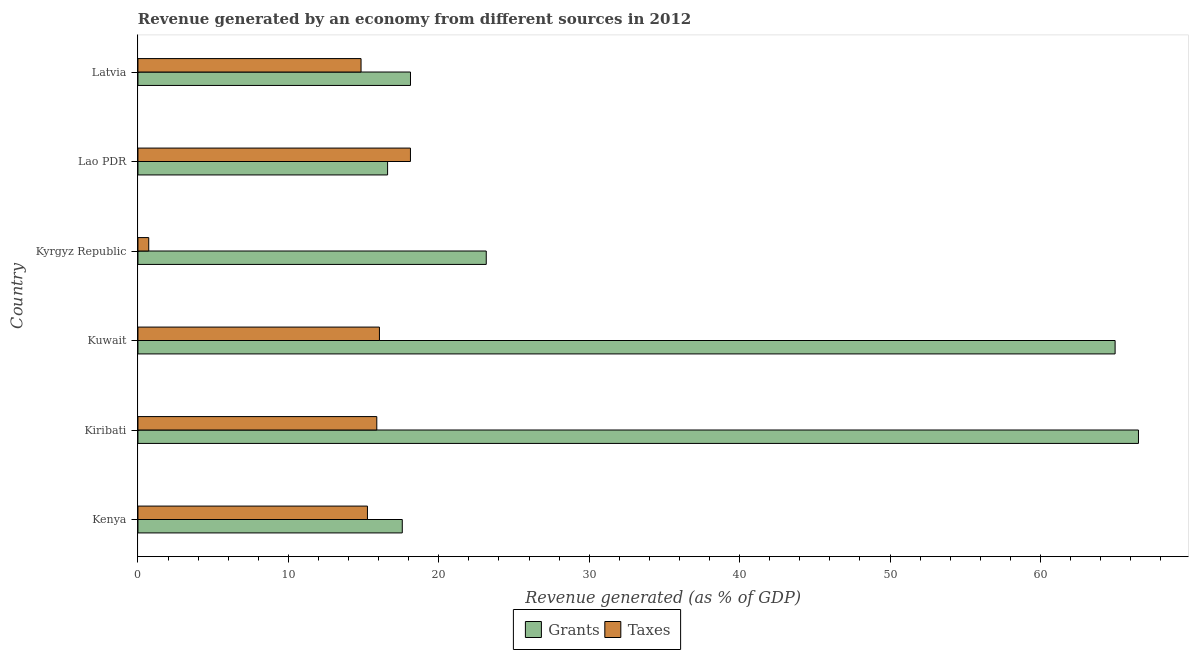How many different coloured bars are there?
Provide a succinct answer. 2. Are the number of bars per tick equal to the number of legend labels?
Provide a succinct answer. Yes. Are the number of bars on each tick of the Y-axis equal?
Your answer should be very brief. Yes. How many bars are there on the 6th tick from the top?
Your answer should be very brief. 2. What is the label of the 6th group of bars from the top?
Ensure brevity in your answer.  Kenya. What is the revenue generated by taxes in Kyrgyz Republic?
Make the answer very short. 0.72. Across all countries, what is the maximum revenue generated by taxes?
Your answer should be very brief. 18.12. Across all countries, what is the minimum revenue generated by taxes?
Provide a short and direct response. 0.72. In which country was the revenue generated by taxes maximum?
Keep it short and to the point. Lao PDR. In which country was the revenue generated by grants minimum?
Your answer should be compact. Lao PDR. What is the total revenue generated by grants in the graph?
Keep it short and to the point. 206.93. What is the difference between the revenue generated by taxes in Kyrgyz Republic and that in Lao PDR?
Give a very brief answer. -17.4. What is the difference between the revenue generated by grants in Kuwait and the revenue generated by taxes in Kiribati?
Your answer should be very brief. 49.09. What is the average revenue generated by taxes per country?
Keep it short and to the point. 13.48. What is the difference between the revenue generated by taxes and revenue generated by grants in Kyrgyz Republic?
Provide a short and direct response. -22.44. Is the revenue generated by taxes in Kyrgyz Republic less than that in Lao PDR?
Offer a terse response. Yes. What is the difference between the highest and the second highest revenue generated by grants?
Provide a succinct answer. 1.55. In how many countries, is the revenue generated by grants greater than the average revenue generated by grants taken over all countries?
Keep it short and to the point. 2. What does the 2nd bar from the top in Latvia represents?
Give a very brief answer. Grants. What does the 1st bar from the bottom in Kiribati represents?
Keep it short and to the point. Grants. Are all the bars in the graph horizontal?
Keep it short and to the point. Yes. Does the graph contain any zero values?
Give a very brief answer. No. Does the graph contain grids?
Offer a terse response. No. Where does the legend appear in the graph?
Provide a succinct answer. Bottom center. How many legend labels are there?
Make the answer very short. 2. How are the legend labels stacked?
Offer a very short reply. Horizontal. What is the title of the graph?
Offer a terse response. Revenue generated by an economy from different sources in 2012. Does "Mobile cellular" appear as one of the legend labels in the graph?
Your answer should be very brief. No. What is the label or title of the X-axis?
Give a very brief answer. Revenue generated (as % of GDP). What is the label or title of the Y-axis?
Keep it short and to the point. Country. What is the Revenue generated (as % of GDP) of Grants in Kenya?
Provide a succinct answer. 17.57. What is the Revenue generated (as % of GDP) of Taxes in Kenya?
Your answer should be very brief. 15.26. What is the Revenue generated (as % of GDP) of Grants in Kiribati?
Give a very brief answer. 66.52. What is the Revenue generated (as % of GDP) of Taxes in Kiribati?
Your answer should be very brief. 15.88. What is the Revenue generated (as % of GDP) of Grants in Kuwait?
Make the answer very short. 64.96. What is the Revenue generated (as % of GDP) in Taxes in Kuwait?
Keep it short and to the point. 16.05. What is the Revenue generated (as % of GDP) of Grants in Kyrgyz Republic?
Offer a very short reply. 23.16. What is the Revenue generated (as % of GDP) of Taxes in Kyrgyz Republic?
Make the answer very short. 0.72. What is the Revenue generated (as % of GDP) in Grants in Lao PDR?
Make the answer very short. 16.6. What is the Revenue generated (as % of GDP) of Taxes in Lao PDR?
Give a very brief answer. 18.12. What is the Revenue generated (as % of GDP) of Grants in Latvia?
Ensure brevity in your answer.  18.12. What is the Revenue generated (as % of GDP) in Taxes in Latvia?
Your answer should be very brief. 14.83. Across all countries, what is the maximum Revenue generated (as % of GDP) in Grants?
Provide a succinct answer. 66.52. Across all countries, what is the maximum Revenue generated (as % of GDP) of Taxes?
Make the answer very short. 18.12. Across all countries, what is the minimum Revenue generated (as % of GDP) in Grants?
Keep it short and to the point. 16.6. Across all countries, what is the minimum Revenue generated (as % of GDP) in Taxes?
Your answer should be very brief. 0.72. What is the total Revenue generated (as % of GDP) in Grants in the graph?
Your answer should be compact. 206.93. What is the total Revenue generated (as % of GDP) in Taxes in the graph?
Your answer should be very brief. 80.86. What is the difference between the Revenue generated (as % of GDP) of Grants in Kenya and that in Kiribati?
Ensure brevity in your answer.  -48.94. What is the difference between the Revenue generated (as % of GDP) of Taxes in Kenya and that in Kiribati?
Make the answer very short. -0.62. What is the difference between the Revenue generated (as % of GDP) in Grants in Kenya and that in Kuwait?
Your answer should be very brief. -47.39. What is the difference between the Revenue generated (as % of GDP) of Taxes in Kenya and that in Kuwait?
Ensure brevity in your answer.  -0.8. What is the difference between the Revenue generated (as % of GDP) in Grants in Kenya and that in Kyrgyz Republic?
Your response must be concise. -5.58. What is the difference between the Revenue generated (as % of GDP) of Taxes in Kenya and that in Kyrgyz Republic?
Provide a short and direct response. 14.54. What is the difference between the Revenue generated (as % of GDP) in Grants in Kenya and that in Lao PDR?
Your answer should be compact. 0.98. What is the difference between the Revenue generated (as % of GDP) of Taxes in Kenya and that in Lao PDR?
Your answer should be compact. -2.86. What is the difference between the Revenue generated (as % of GDP) in Grants in Kenya and that in Latvia?
Your response must be concise. -0.55. What is the difference between the Revenue generated (as % of GDP) in Taxes in Kenya and that in Latvia?
Provide a succinct answer. 0.43. What is the difference between the Revenue generated (as % of GDP) in Grants in Kiribati and that in Kuwait?
Provide a short and direct response. 1.55. What is the difference between the Revenue generated (as % of GDP) in Taxes in Kiribati and that in Kuwait?
Give a very brief answer. -0.18. What is the difference between the Revenue generated (as % of GDP) of Grants in Kiribati and that in Kyrgyz Republic?
Offer a terse response. 43.36. What is the difference between the Revenue generated (as % of GDP) of Taxes in Kiribati and that in Kyrgyz Republic?
Ensure brevity in your answer.  15.16. What is the difference between the Revenue generated (as % of GDP) in Grants in Kiribati and that in Lao PDR?
Your response must be concise. 49.92. What is the difference between the Revenue generated (as % of GDP) of Taxes in Kiribati and that in Lao PDR?
Provide a succinct answer. -2.24. What is the difference between the Revenue generated (as % of GDP) of Grants in Kiribati and that in Latvia?
Your answer should be compact. 48.4. What is the difference between the Revenue generated (as % of GDP) in Taxes in Kiribati and that in Latvia?
Keep it short and to the point. 1.05. What is the difference between the Revenue generated (as % of GDP) of Grants in Kuwait and that in Kyrgyz Republic?
Your response must be concise. 41.81. What is the difference between the Revenue generated (as % of GDP) in Taxes in Kuwait and that in Kyrgyz Republic?
Provide a succinct answer. 15.34. What is the difference between the Revenue generated (as % of GDP) of Grants in Kuwait and that in Lao PDR?
Your response must be concise. 48.37. What is the difference between the Revenue generated (as % of GDP) of Taxes in Kuwait and that in Lao PDR?
Offer a terse response. -2.06. What is the difference between the Revenue generated (as % of GDP) of Grants in Kuwait and that in Latvia?
Your answer should be very brief. 46.85. What is the difference between the Revenue generated (as % of GDP) of Taxes in Kuwait and that in Latvia?
Your response must be concise. 1.22. What is the difference between the Revenue generated (as % of GDP) of Grants in Kyrgyz Republic and that in Lao PDR?
Offer a terse response. 6.56. What is the difference between the Revenue generated (as % of GDP) of Taxes in Kyrgyz Republic and that in Lao PDR?
Offer a terse response. -17.4. What is the difference between the Revenue generated (as % of GDP) of Grants in Kyrgyz Republic and that in Latvia?
Offer a terse response. 5.04. What is the difference between the Revenue generated (as % of GDP) in Taxes in Kyrgyz Republic and that in Latvia?
Your answer should be very brief. -14.12. What is the difference between the Revenue generated (as % of GDP) in Grants in Lao PDR and that in Latvia?
Offer a very short reply. -1.52. What is the difference between the Revenue generated (as % of GDP) in Taxes in Lao PDR and that in Latvia?
Provide a short and direct response. 3.28. What is the difference between the Revenue generated (as % of GDP) of Grants in Kenya and the Revenue generated (as % of GDP) of Taxes in Kiribati?
Your response must be concise. 1.7. What is the difference between the Revenue generated (as % of GDP) of Grants in Kenya and the Revenue generated (as % of GDP) of Taxes in Kuwait?
Provide a succinct answer. 1.52. What is the difference between the Revenue generated (as % of GDP) in Grants in Kenya and the Revenue generated (as % of GDP) in Taxes in Kyrgyz Republic?
Provide a succinct answer. 16.86. What is the difference between the Revenue generated (as % of GDP) of Grants in Kenya and the Revenue generated (as % of GDP) of Taxes in Lao PDR?
Give a very brief answer. -0.54. What is the difference between the Revenue generated (as % of GDP) of Grants in Kenya and the Revenue generated (as % of GDP) of Taxes in Latvia?
Offer a very short reply. 2.74. What is the difference between the Revenue generated (as % of GDP) in Grants in Kiribati and the Revenue generated (as % of GDP) in Taxes in Kuwait?
Offer a very short reply. 50.46. What is the difference between the Revenue generated (as % of GDP) in Grants in Kiribati and the Revenue generated (as % of GDP) in Taxes in Kyrgyz Republic?
Provide a short and direct response. 65.8. What is the difference between the Revenue generated (as % of GDP) of Grants in Kiribati and the Revenue generated (as % of GDP) of Taxes in Lao PDR?
Give a very brief answer. 48.4. What is the difference between the Revenue generated (as % of GDP) in Grants in Kiribati and the Revenue generated (as % of GDP) in Taxes in Latvia?
Keep it short and to the point. 51.69. What is the difference between the Revenue generated (as % of GDP) of Grants in Kuwait and the Revenue generated (as % of GDP) of Taxes in Kyrgyz Republic?
Offer a very short reply. 64.25. What is the difference between the Revenue generated (as % of GDP) in Grants in Kuwait and the Revenue generated (as % of GDP) in Taxes in Lao PDR?
Give a very brief answer. 46.85. What is the difference between the Revenue generated (as % of GDP) in Grants in Kuwait and the Revenue generated (as % of GDP) in Taxes in Latvia?
Make the answer very short. 50.13. What is the difference between the Revenue generated (as % of GDP) in Grants in Kyrgyz Republic and the Revenue generated (as % of GDP) in Taxes in Lao PDR?
Offer a very short reply. 5.04. What is the difference between the Revenue generated (as % of GDP) of Grants in Kyrgyz Republic and the Revenue generated (as % of GDP) of Taxes in Latvia?
Offer a very short reply. 8.32. What is the difference between the Revenue generated (as % of GDP) in Grants in Lao PDR and the Revenue generated (as % of GDP) in Taxes in Latvia?
Keep it short and to the point. 1.77. What is the average Revenue generated (as % of GDP) of Grants per country?
Keep it short and to the point. 34.49. What is the average Revenue generated (as % of GDP) of Taxes per country?
Provide a short and direct response. 13.48. What is the difference between the Revenue generated (as % of GDP) of Grants and Revenue generated (as % of GDP) of Taxes in Kenya?
Offer a terse response. 2.32. What is the difference between the Revenue generated (as % of GDP) of Grants and Revenue generated (as % of GDP) of Taxes in Kiribati?
Provide a short and direct response. 50.64. What is the difference between the Revenue generated (as % of GDP) of Grants and Revenue generated (as % of GDP) of Taxes in Kuwait?
Make the answer very short. 48.91. What is the difference between the Revenue generated (as % of GDP) of Grants and Revenue generated (as % of GDP) of Taxes in Kyrgyz Republic?
Make the answer very short. 22.44. What is the difference between the Revenue generated (as % of GDP) of Grants and Revenue generated (as % of GDP) of Taxes in Lao PDR?
Make the answer very short. -1.52. What is the difference between the Revenue generated (as % of GDP) in Grants and Revenue generated (as % of GDP) in Taxes in Latvia?
Give a very brief answer. 3.29. What is the ratio of the Revenue generated (as % of GDP) in Grants in Kenya to that in Kiribati?
Offer a very short reply. 0.26. What is the ratio of the Revenue generated (as % of GDP) of Taxes in Kenya to that in Kiribati?
Provide a short and direct response. 0.96. What is the ratio of the Revenue generated (as % of GDP) in Grants in Kenya to that in Kuwait?
Provide a short and direct response. 0.27. What is the ratio of the Revenue generated (as % of GDP) in Taxes in Kenya to that in Kuwait?
Ensure brevity in your answer.  0.95. What is the ratio of the Revenue generated (as % of GDP) in Grants in Kenya to that in Kyrgyz Republic?
Give a very brief answer. 0.76. What is the ratio of the Revenue generated (as % of GDP) of Taxes in Kenya to that in Kyrgyz Republic?
Offer a terse response. 21.3. What is the ratio of the Revenue generated (as % of GDP) of Grants in Kenya to that in Lao PDR?
Give a very brief answer. 1.06. What is the ratio of the Revenue generated (as % of GDP) in Taxes in Kenya to that in Lao PDR?
Provide a succinct answer. 0.84. What is the ratio of the Revenue generated (as % of GDP) of Grants in Kenya to that in Latvia?
Offer a very short reply. 0.97. What is the ratio of the Revenue generated (as % of GDP) of Taxes in Kenya to that in Latvia?
Offer a terse response. 1.03. What is the ratio of the Revenue generated (as % of GDP) in Grants in Kiribati to that in Kuwait?
Give a very brief answer. 1.02. What is the ratio of the Revenue generated (as % of GDP) in Taxes in Kiribati to that in Kuwait?
Your answer should be very brief. 0.99. What is the ratio of the Revenue generated (as % of GDP) in Grants in Kiribati to that in Kyrgyz Republic?
Provide a short and direct response. 2.87. What is the ratio of the Revenue generated (as % of GDP) in Taxes in Kiribati to that in Kyrgyz Republic?
Provide a short and direct response. 22.17. What is the ratio of the Revenue generated (as % of GDP) of Grants in Kiribati to that in Lao PDR?
Ensure brevity in your answer.  4.01. What is the ratio of the Revenue generated (as % of GDP) of Taxes in Kiribati to that in Lao PDR?
Your response must be concise. 0.88. What is the ratio of the Revenue generated (as % of GDP) in Grants in Kiribati to that in Latvia?
Provide a short and direct response. 3.67. What is the ratio of the Revenue generated (as % of GDP) in Taxes in Kiribati to that in Latvia?
Provide a short and direct response. 1.07. What is the ratio of the Revenue generated (as % of GDP) in Grants in Kuwait to that in Kyrgyz Republic?
Offer a very short reply. 2.81. What is the ratio of the Revenue generated (as % of GDP) in Taxes in Kuwait to that in Kyrgyz Republic?
Provide a succinct answer. 22.41. What is the ratio of the Revenue generated (as % of GDP) of Grants in Kuwait to that in Lao PDR?
Your response must be concise. 3.91. What is the ratio of the Revenue generated (as % of GDP) in Taxes in Kuwait to that in Lao PDR?
Ensure brevity in your answer.  0.89. What is the ratio of the Revenue generated (as % of GDP) of Grants in Kuwait to that in Latvia?
Offer a terse response. 3.59. What is the ratio of the Revenue generated (as % of GDP) of Taxes in Kuwait to that in Latvia?
Provide a succinct answer. 1.08. What is the ratio of the Revenue generated (as % of GDP) in Grants in Kyrgyz Republic to that in Lao PDR?
Your answer should be compact. 1.4. What is the ratio of the Revenue generated (as % of GDP) of Taxes in Kyrgyz Republic to that in Lao PDR?
Your answer should be compact. 0.04. What is the ratio of the Revenue generated (as % of GDP) in Grants in Kyrgyz Republic to that in Latvia?
Provide a short and direct response. 1.28. What is the ratio of the Revenue generated (as % of GDP) of Taxes in Kyrgyz Republic to that in Latvia?
Make the answer very short. 0.05. What is the ratio of the Revenue generated (as % of GDP) in Grants in Lao PDR to that in Latvia?
Offer a very short reply. 0.92. What is the ratio of the Revenue generated (as % of GDP) in Taxes in Lao PDR to that in Latvia?
Provide a succinct answer. 1.22. What is the difference between the highest and the second highest Revenue generated (as % of GDP) of Grants?
Make the answer very short. 1.55. What is the difference between the highest and the second highest Revenue generated (as % of GDP) of Taxes?
Provide a short and direct response. 2.06. What is the difference between the highest and the lowest Revenue generated (as % of GDP) of Grants?
Provide a succinct answer. 49.92. What is the difference between the highest and the lowest Revenue generated (as % of GDP) of Taxes?
Offer a very short reply. 17.4. 